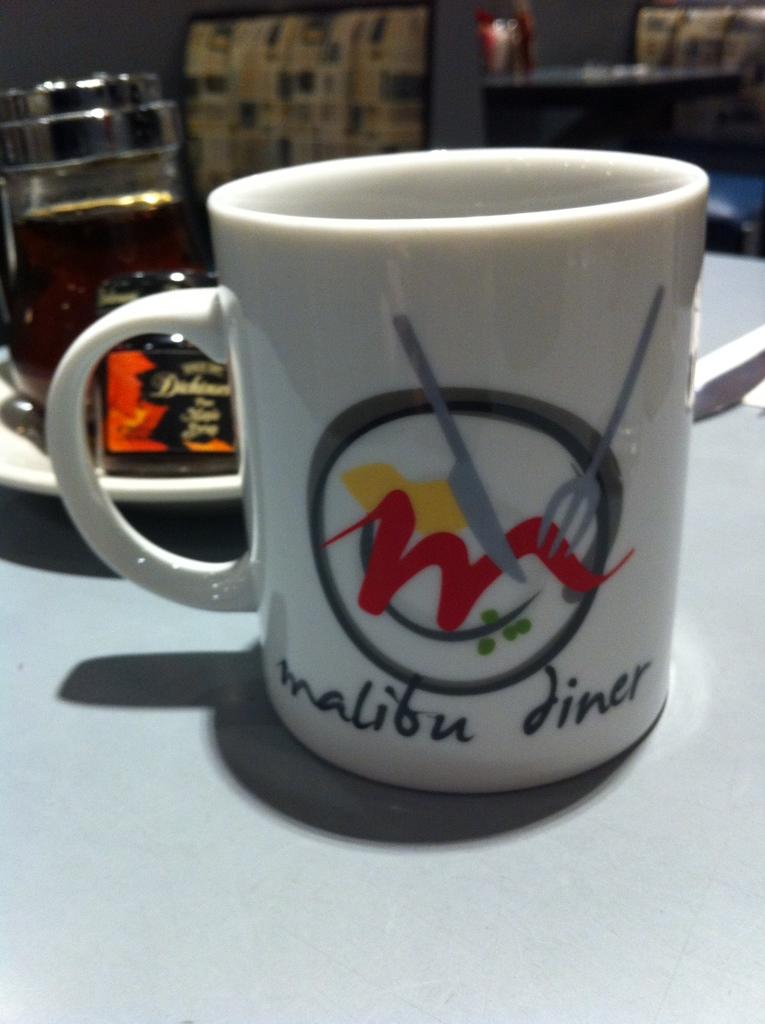Provide a one-sentence caption for the provided image. Coffee mug sitting on a table in a restaurant with the name of the establishment and their logo on the mug. 